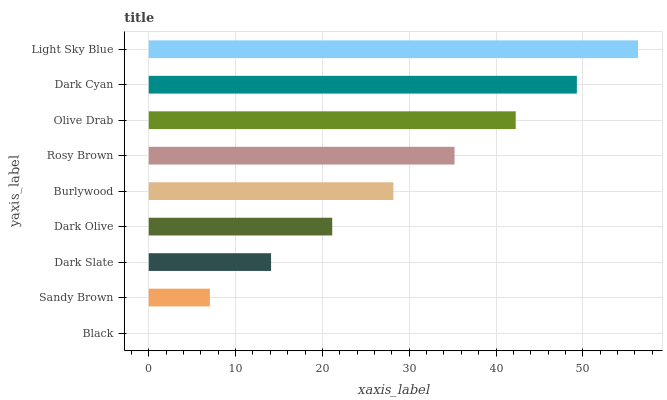Is Black the minimum?
Answer yes or no. Yes. Is Light Sky Blue the maximum?
Answer yes or no. Yes. Is Sandy Brown the minimum?
Answer yes or no. No. Is Sandy Brown the maximum?
Answer yes or no. No. Is Sandy Brown greater than Black?
Answer yes or no. Yes. Is Black less than Sandy Brown?
Answer yes or no. Yes. Is Black greater than Sandy Brown?
Answer yes or no. No. Is Sandy Brown less than Black?
Answer yes or no. No. Is Burlywood the high median?
Answer yes or no. Yes. Is Burlywood the low median?
Answer yes or no. Yes. Is Light Sky Blue the high median?
Answer yes or no. No. Is Dark Slate the low median?
Answer yes or no. No. 